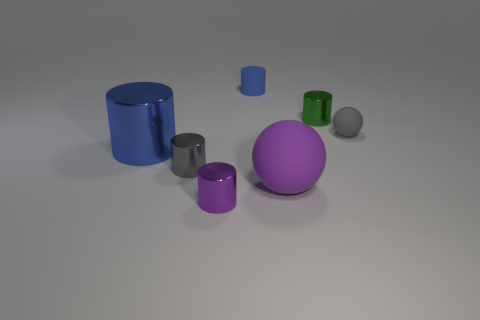There is a object that is the same color as the big sphere; what is its shape?
Your answer should be compact. Cylinder. How many other things are the same material as the green object?
Your answer should be compact. 3. Are the large thing that is left of the purple metal cylinder and the blue cylinder behind the gray ball made of the same material?
Make the answer very short. No. How many things are behind the big blue cylinder and right of the blue rubber thing?
Make the answer very short. 2. Is there a red thing of the same shape as the blue metal thing?
Ensure brevity in your answer.  No. What shape is the gray matte thing that is the same size as the green metallic thing?
Provide a succinct answer. Sphere. Are there an equal number of large matte spheres that are behind the large purple rubber object and large purple objects that are on the right side of the purple cylinder?
Ensure brevity in your answer.  No. How big is the blue thing that is behind the large metal thing that is left of the tiny gray sphere?
Make the answer very short. Small. Is there a blue metallic thing of the same size as the gray metal object?
Your response must be concise. No. The small object that is the same material as the small blue cylinder is what color?
Provide a succinct answer. Gray. 